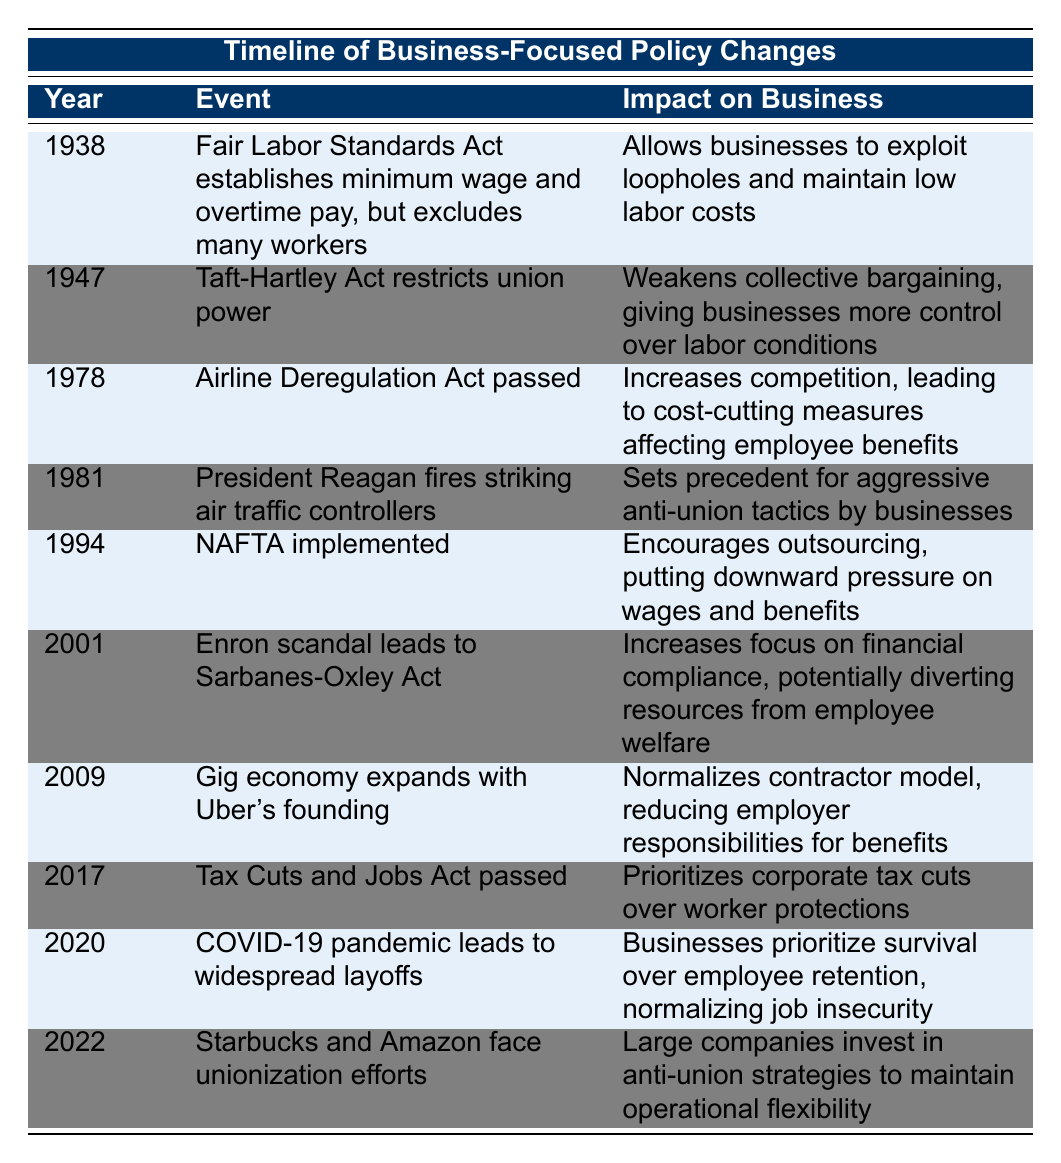What year was the Taft-Hartley Act enacted? The Taft-Hartley Act is listed as an event under the year 1947 in the table.
Answer: 1947 What impact did the Fair Labor Standards Act have on businesses? The impact listed under the Fair Labor Standards Act is that it allows businesses to exploit loopholes and maintain low labor costs.
Answer: Allows businesses to exploit loopholes and maintain low labor costs How many events are related to outsourcing? The table mentions two events related to outsourcing: NAFTA implemented in 1994 and the expansion of the gig economy with Uber's founding in 2009. Thus, the total is 2.
Answer: 2 Is the COVID-19 pandemic listed as an event? Yes, the table includes COVID-19 pandemic in the year 2020, indicating widespread layoffs.
Answer: Yes Which event in the table could be considered a precedent for aggressive anti-union tactics? The event in the table that could be considered a precedent for aggressive anti-union tactics is President Reagan firing striking air traffic controllers in 1981.
Answer: President Reagan fires striking air traffic controllers What are the years in which airline-related policies were enacted, and how many such events exist? The Airline Deregulation Act was passed in 1978, which is the only event related to airlines in the table. Therefore, there is 1 event in total.
Answer: 1 What is the average year of the events listed in the table? To find the average, we first sum all the years: 1938 + 1947 + 1978 + 1981 + 1994 + 2001 + 2009 + 2017 + 2020 + 2022 = 20187. There are 10 events, so the average year is 20187 / 10 = 2018.7, which rounds to 2019.
Answer: 2019 How does the impact of the Tax Cuts and Jobs Act contrast with employee protections? The Tax Cuts and Jobs Act passed in 2017 prioritizes corporate tax cuts over worker protections, highlighting a business-focused approach rather than one that supports employees.'
Answer: Prioritizes corporate tax cuts over worker protections Did the Enron scandal lead to legislation that focused more on business compliance? Yes, the Enron scandal led to the Sarbanes-Oxley Act, which increased focus on financial compliance potentially diverting resources from employee welfare.
Answer: Yes 